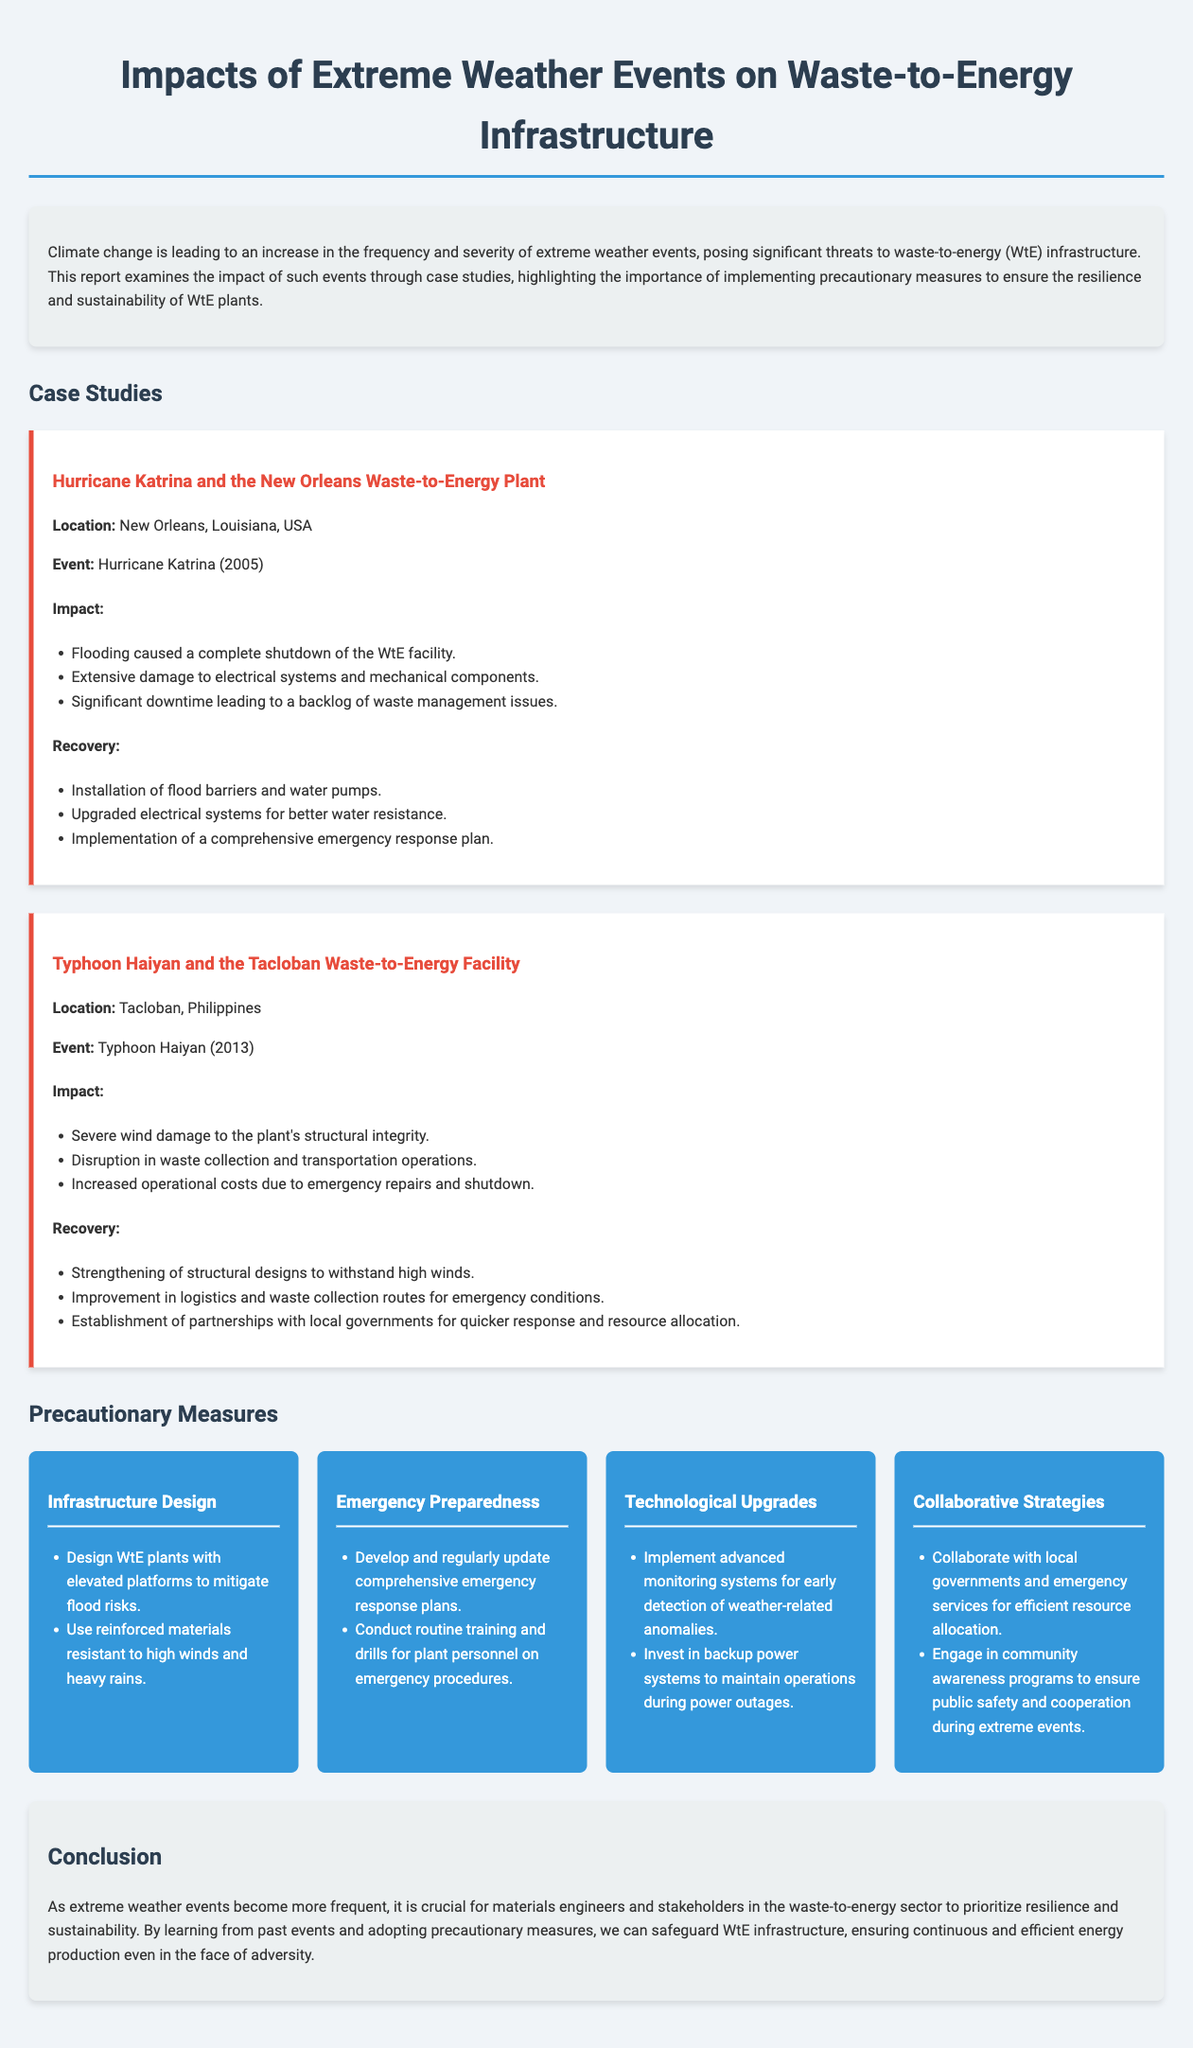What was the event that impacted the New Orleans WtE plant? The document states that Hurricane Katrina in 2005 impacted the New Orleans WtE plant.
Answer: Hurricane Katrina What were the recovery measures taken after Typhoon Haiyan? The document lists several recovery measures, including strengthening structural designs and improving logistics.
Answer: Strengthening of structural designs, improvement in logistics What natural disaster caused flooding at the New Orleans facility? The report indicates that flooding was caused by Hurricane Katrina.
Answer: Hurricane Katrina What precautionary measure involves partnerships with local governments? The document mentions collaborative strategies involving partnerships with local governments for resource allocation.
Answer: Collaborative strategies How long ago did Typhoon Haiyan occur? The document reports that Typhoon Haiyan took place in 2013, which is 10 years ago from the current year 2023.
Answer: 10 years What type of systems should be implemented for early detection? The report recommends implementing advanced monitoring systems for early detection of weather-related anomalies.
Answer: Advanced monitoring systems What was one of the significant damages caused by Hurricane Katrina? The document notes extensive damage to electrical systems and mechanical components at the New Orleans plant.
Answer: Damage to electrical systems and mechanical components What is one design measure recommended for WtE plants to mitigate flood risk? The document indicates designing WtE plants with elevated platforms as a measure to mitigate flood risks.
Answer: Elevated platforms 